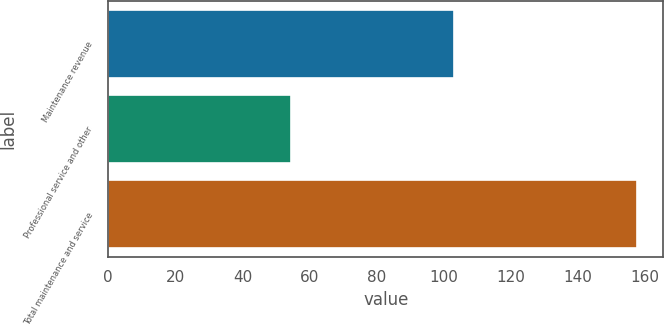<chart> <loc_0><loc_0><loc_500><loc_500><bar_chart><fcel>Maintenance revenue<fcel>Professional service and other<fcel>Total maintenance and service<nl><fcel>103.1<fcel>54.5<fcel>157.6<nl></chart> 